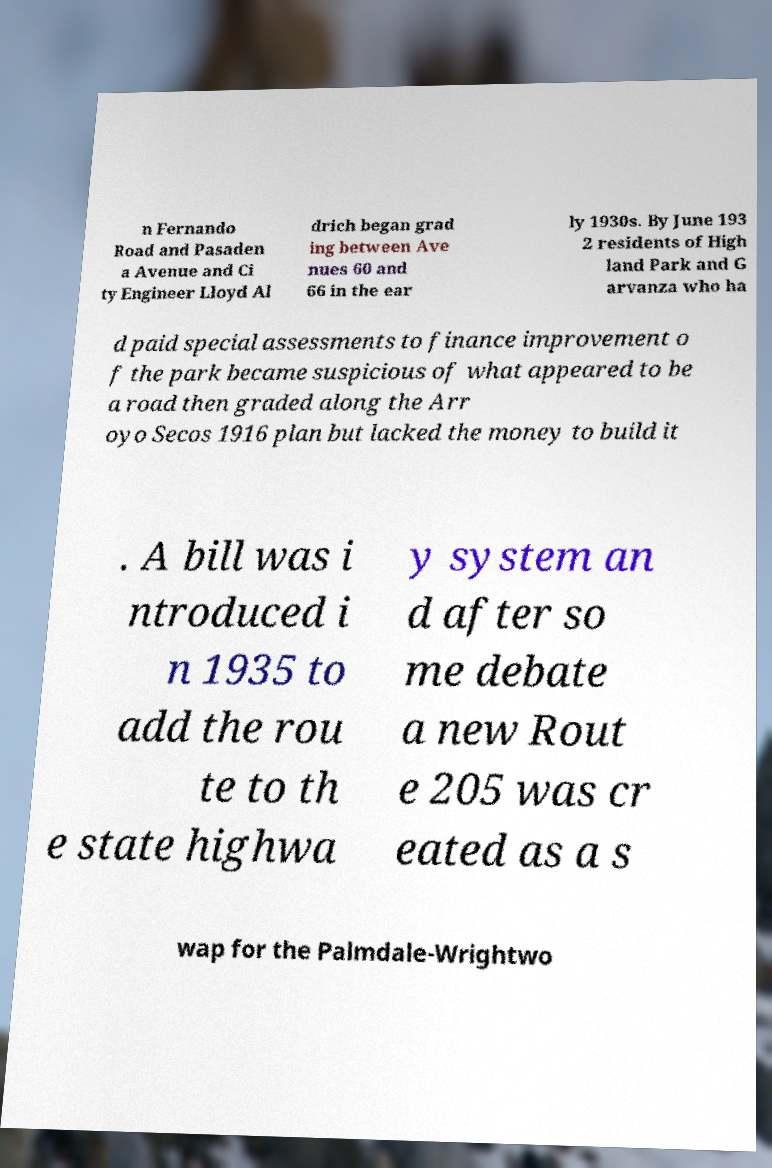What messages or text are displayed in this image? I need them in a readable, typed format. n Fernando Road and Pasaden a Avenue and Ci ty Engineer Lloyd Al drich began grad ing between Ave nues 60 and 66 in the ear ly 1930s. By June 193 2 residents of High land Park and G arvanza who ha d paid special assessments to finance improvement o f the park became suspicious of what appeared to be a road then graded along the Arr oyo Secos 1916 plan but lacked the money to build it . A bill was i ntroduced i n 1935 to add the rou te to th e state highwa y system an d after so me debate a new Rout e 205 was cr eated as a s wap for the Palmdale-Wrightwo 